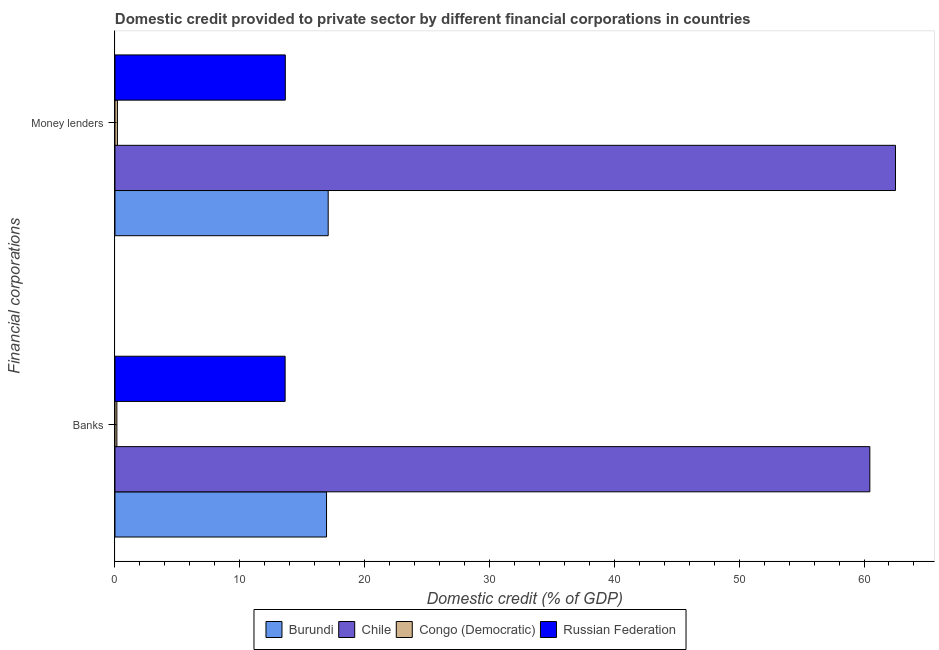Are the number of bars per tick equal to the number of legend labels?
Give a very brief answer. Yes. Are the number of bars on each tick of the Y-axis equal?
Ensure brevity in your answer.  Yes. How many bars are there on the 2nd tick from the top?
Offer a very short reply. 4. What is the label of the 1st group of bars from the top?
Give a very brief answer. Money lenders. What is the domestic credit provided by money lenders in Burundi?
Make the answer very short. 17.08. Across all countries, what is the maximum domestic credit provided by banks?
Your answer should be compact. 60.47. Across all countries, what is the minimum domestic credit provided by money lenders?
Your answer should be compact. 0.2. In which country was the domestic credit provided by banks minimum?
Your answer should be compact. Congo (Democratic). What is the total domestic credit provided by money lenders in the graph?
Give a very brief answer. 93.44. What is the difference between the domestic credit provided by money lenders in Congo (Democratic) and that in Burundi?
Your answer should be compact. -16.88. What is the difference between the domestic credit provided by money lenders in Burundi and the domestic credit provided by banks in Congo (Democratic)?
Give a very brief answer. 16.93. What is the average domestic credit provided by money lenders per country?
Your answer should be compact. 23.36. What is the difference between the domestic credit provided by money lenders and domestic credit provided by banks in Burundi?
Offer a terse response. 0.13. In how many countries, is the domestic credit provided by money lenders greater than 32 %?
Your answer should be very brief. 1. What is the ratio of the domestic credit provided by banks in Chile to that in Burundi?
Your response must be concise. 3.57. In how many countries, is the domestic credit provided by banks greater than the average domestic credit provided by banks taken over all countries?
Provide a succinct answer. 1. What does the 4th bar from the top in Money lenders represents?
Make the answer very short. Burundi. What does the 4th bar from the bottom in Money lenders represents?
Offer a terse response. Russian Federation. Are all the bars in the graph horizontal?
Offer a very short reply. Yes. How many countries are there in the graph?
Ensure brevity in your answer.  4. Does the graph contain grids?
Provide a succinct answer. No. How many legend labels are there?
Your answer should be compact. 4. How are the legend labels stacked?
Offer a terse response. Horizontal. What is the title of the graph?
Provide a succinct answer. Domestic credit provided to private sector by different financial corporations in countries. Does "Mongolia" appear as one of the legend labels in the graph?
Give a very brief answer. No. What is the label or title of the X-axis?
Your answer should be compact. Domestic credit (% of GDP). What is the label or title of the Y-axis?
Offer a terse response. Financial corporations. What is the Domestic credit (% of GDP) of Burundi in Banks?
Provide a short and direct response. 16.95. What is the Domestic credit (% of GDP) of Chile in Banks?
Your answer should be compact. 60.47. What is the Domestic credit (% of GDP) of Congo (Democratic) in Banks?
Provide a short and direct response. 0.15. What is the Domestic credit (% of GDP) of Russian Federation in Banks?
Your answer should be compact. 13.63. What is the Domestic credit (% of GDP) in Burundi in Money lenders?
Offer a very short reply. 17.08. What is the Domestic credit (% of GDP) of Chile in Money lenders?
Keep it short and to the point. 62.52. What is the Domestic credit (% of GDP) in Congo (Democratic) in Money lenders?
Give a very brief answer. 0.2. What is the Domestic credit (% of GDP) in Russian Federation in Money lenders?
Provide a short and direct response. 13.65. Across all Financial corporations, what is the maximum Domestic credit (% of GDP) in Burundi?
Give a very brief answer. 17.08. Across all Financial corporations, what is the maximum Domestic credit (% of GDP) of Chile?
Your response must be concise. 62.52. Across all Financial corporations, what is the maximum Domestic credit (% of GDP) in Congo (Democratic)?
Offer a very short reply. 0.2. Across all Financial corporations, what is the maximum Domestic credit (% of GDP) of Russian Federation?
Your answer should be very brief. 13.65. Across all Financial corporations, what is the minimum Domestic credit (% of GDP) of Burundi?
Offer a very short reply. 16.95. Across all Financial corporations, what is the minimum Domestic credit (% of GDP) of Chile?
Your answer should be very brief. 60.47. Across all Financial corporations, what is the minimum Domestic credit (% of GDP) in Congo (Democratic)?
Your answer should be very brief. 0.15. Across all Financial corporations, what is the minimum Domestic credit (% of GDP) in Russian Federation?
Your response must be concise. 13.63. What is the total Domestic credit (% of GDP) in Burundi in the graph?
Ensure brevity in your answer.  34.03. What is the total Domestic credit (% of GDP) in Chile in the graph?
Make the answer very short. 122.99. What is the total Domestic credit (% of GDP) of Congo (Democratic) in the graph?
Provide a short and direct response. 0.35. What is the total Domestic credit (% of GDP) of Russian Federation in the graph?
Make the answer very short. 27.28. What is the difference between the Domestic credit (% of GDP) in Burundi in Banks and that in Money lenders?
Your answer should be compact. -0.13. What is the difference between the Domestic credit (% of GDP) of Chile in Banks and that in Money lenders?
Provide a short and direct response. -2.05. What is the difference between the Domestic credit (% of GDP) in Congo (Democratic) in Banks and that in Money lenders?
Give a very brief answer. -0.04. What is the difference between the Domestic credit (% of GDP) of Russian Federation in Banks and that in Money lenders?
Provide a succinct answer. -0.02. What is the difference between the Domestic credit (% of GDP) in Burundi in Banks and the Domestic credit (% of GDP) in Chile in Money lenders?
Provide a succinct answer. -45.57. What is the difference between the Domestic credit (% of GDP) in Burundi in Banks and the Domestic credit (% of GDP) in Congo (Democratic) in Money lenders?
Your response must be concise. 16.75. What is the difference between the Domestic credit (% of GDP) in Burundi in Banks and the Domestic credit (% of GDP) in Russian Federation in Money lenders?
Give a very brief answer. 3.3. What is the difference between the Domestic credit (% of GDP) of Chile in Banks and the Domestic credit (% of GDP) of Congo (Democratic) in Money lenders?
Provide a succinct answer. 60.27. What is the difference between the Domestic credit (% of GDP) in Chile in Banks and the Domestic credit (% of GDP) in Russian Federation in Money lenders?
Offer a very short reply. 46.82. What is the difference between the Domestic credit (% of GDP) in Congo (Democratic) in Banks and the Domestic credit (% of GDP) in Russian Federation in Money lenders?
Offer a very short reply. -13.49. What is the average Domestic credit (% of GDP) in Burundi per Financial corporations?
Keep it short and to the point. 17.01. What is the average Domestic credit (% of GDP) in Chile per Financial corporations?
Provide a short and direct response. 61.49. What is the average Domestic credit (% of GDP) of Congo (Democratic) per Financial corporations?
Offer a terse response. 0.18. What is the average Domestic credit (% of GDP) of Russian Federation per Financial corporations?
Offer a very short reply. 13.64. What is the difference between the Domestic credit (% of GDP) in Burundi and Domestic credit (% of GDP) in Chile in Banks?
Offer a very short reply. -43.52. What is the difference between the Domestic credit (% of GDP) in Burundi and Domestic credit (% of GDP) in Congo (Democratic) in Banks?
Provide a succinct answer. 16.79. What is the difference between the Domestic credit (% of GDP) in Burundi and Domestic credit (% of GDP) in Russian Federation in Banks?
Your answer should be compact. 3.32. What is the difference between the Domestic credit (% of GDP) of Chile and Domestic credit (% of GDP) of Congo (Democratic) in Banks?
Provide a succinct answer. 60.31. What is the difference between the Domestic credit (% of GDP) of Chile and Domestic credit (% of GDP) of Russian Federation in Banks?
Provide a short and direct response. 46.84. What is the difference between the Domestic credit (% of GDP) of Congo (Democratic) and Domestic credit (% of GDP) of Russian Federation in Banks?
Offer a very short reply. -13.48. What is the difference between the Domestic credit (% of GDP) of Burundi and Domestic credit (% of GDP) of Chile in Money lenders?
Provide a succinct answer. -45.44. What is the difference between the Domestic credit (% of GDP) of Burundi and Domestic credit (% of GDP) of Congo (Democratic) in Money lenders?
Provide a short and direct response. 16.88. What is the difference between the Domestic credit (% of GDP) of Burundi and Domestic credit (% of GDP) of Russian Federation in Money lenders?
Provide a succinct answer. 3.43. What is the difference between the Domestic credit (% of GDP) of Chile and Domestic credit (% of GDP) of Congo (Democratic) in Money lenders?
Offer a terse response. 62.32. What is the difference between the Domestic credit (% of GDP) in Chile and Domestic credit (% of GDP) in Russian Federation in Money lenders?
Keep it short and to the point. 48.87. What is the difference between the Domestic credit (% of GDP) in Congo (Democratic) and Domestic credit (% of GDP) in Russian Federation in Money lenders?
Give a very brief answer. -13.45. What is the ratio of the Domestic credit (% of GDP) of Chile in Banks to that in Money lenders?
Keep it short and to the point. 0.97. What is the ratio of the Domestic credit (% of GDP) in Congo (Democratic) in Banks to that in Money lenders?
Give a very brief answer. 0.78. What is the ratio of the Domestic credit (% of GDP) in Russian Federation in Banks to that in Money lenders?
Provide a succinct answer. 1. What is the difference between the highest and the second highest Domestic credit (% of GDP) of Burundi?
Make the answer very short. 0.13. What is the difference between the highest and the second highest Domestic credit (% of GDP) of Chile?
Your answer should be compact. 2.05. What is the difference between the highest and the second highest Domestic credit (% of GDP) in Congo (Democratic)?
Provide a short and direct response. 0.04. What is the difference between the highest and the second highest Domestic credit (% of GDP) of Russian Federation?
Make the answer very short. 0.02. What is the difference between the highest and the lowest Domestic credit (% of GDP) of Burundi?
Make the answer very short. 0.13. What is the difference between the highest and the lowest Domestic credit (% of GDP) in Chile?
Provide a succinct answer. 2.05. What is the difference between the highest and the lowest Domestic credit (% of GDP) in Congo (Democratic)?
Your answer should be very brief. 0.04. What is the difference between the highest and the lowest Domestic credit (% of GDP) of Russian Federation?
Offer a very short reply. 0.02. 